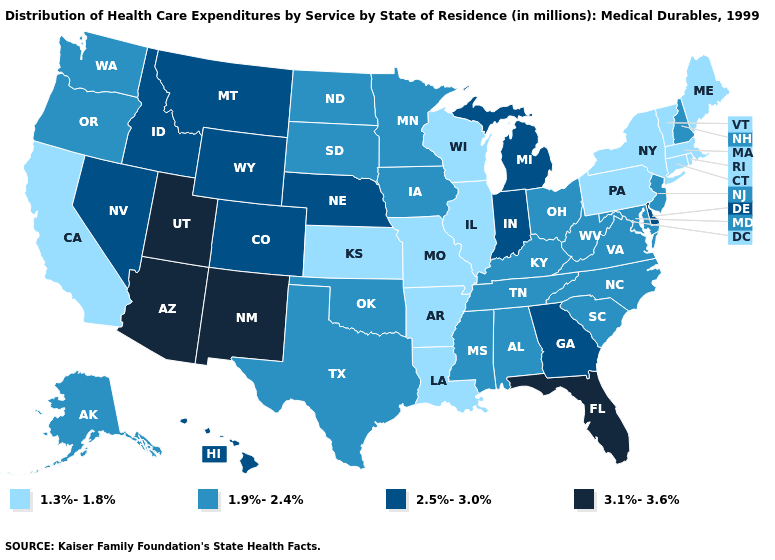Which states hav the highest value in the West?
Answer briefly. Arizona, New Mexico, Utah. Among the states that border Missouri , which have the lowest value?
Quick response, please. Arkansas, Illinois, Kansas. What is the lowest value in states that border Rhode Island?
Be succinct. 1.3%-1.8%. Which states have the highest value in the USA?
Write a very short answer. Arizona, Florida, New Mexico, Utah. Does California have the lowest value in the West?
Give a very brief answer. Yes. What is the lowest value in states that border Kentucky?
Concise answer only. 1.3%-1.8%. What is the highest value in states that border Texas?
Concise answer only. 3.1%-3.6%. Name the states that have a value in the range 2.5%-3.0%?
Write a very short answer. Colorado, Delaware, Georgia, Hawaii, Idaho, Indiana, Michigan, Montana, Nebraska, Nevada, Wyoming. Does New Jersey have the same value as Pennsylvania?
Be succinct. No. Name the states that have a value in the range 1.3%-1.8%?
Short answer required. Arkansas, California, Connecticut, Illinois, Kansas, Louisiana, Maine, Massachusetts, Missouri, New York, Pennsylvania, Rhode Island, Vermont, Wisconsin. Among the states that border Colorado , does Arizona have the highest value?
Keep it brief. Yes. What is the lowest value in the USA?
Concise answer only. 1.3%-1.8%. Name the states that have a value in the range 2.5%-3.0%?
Give a very brief answer. Colorado, Delaware, Georgia, Hawaii, Idaho, Indiana, Michigan, Montana, Nebraska, Nevada, Wyoming. Does Idaho have the highest value in the West?
Concise answer only. No. Does Connecticut have the highest value in the Northeast?
Concise answer only. No. 